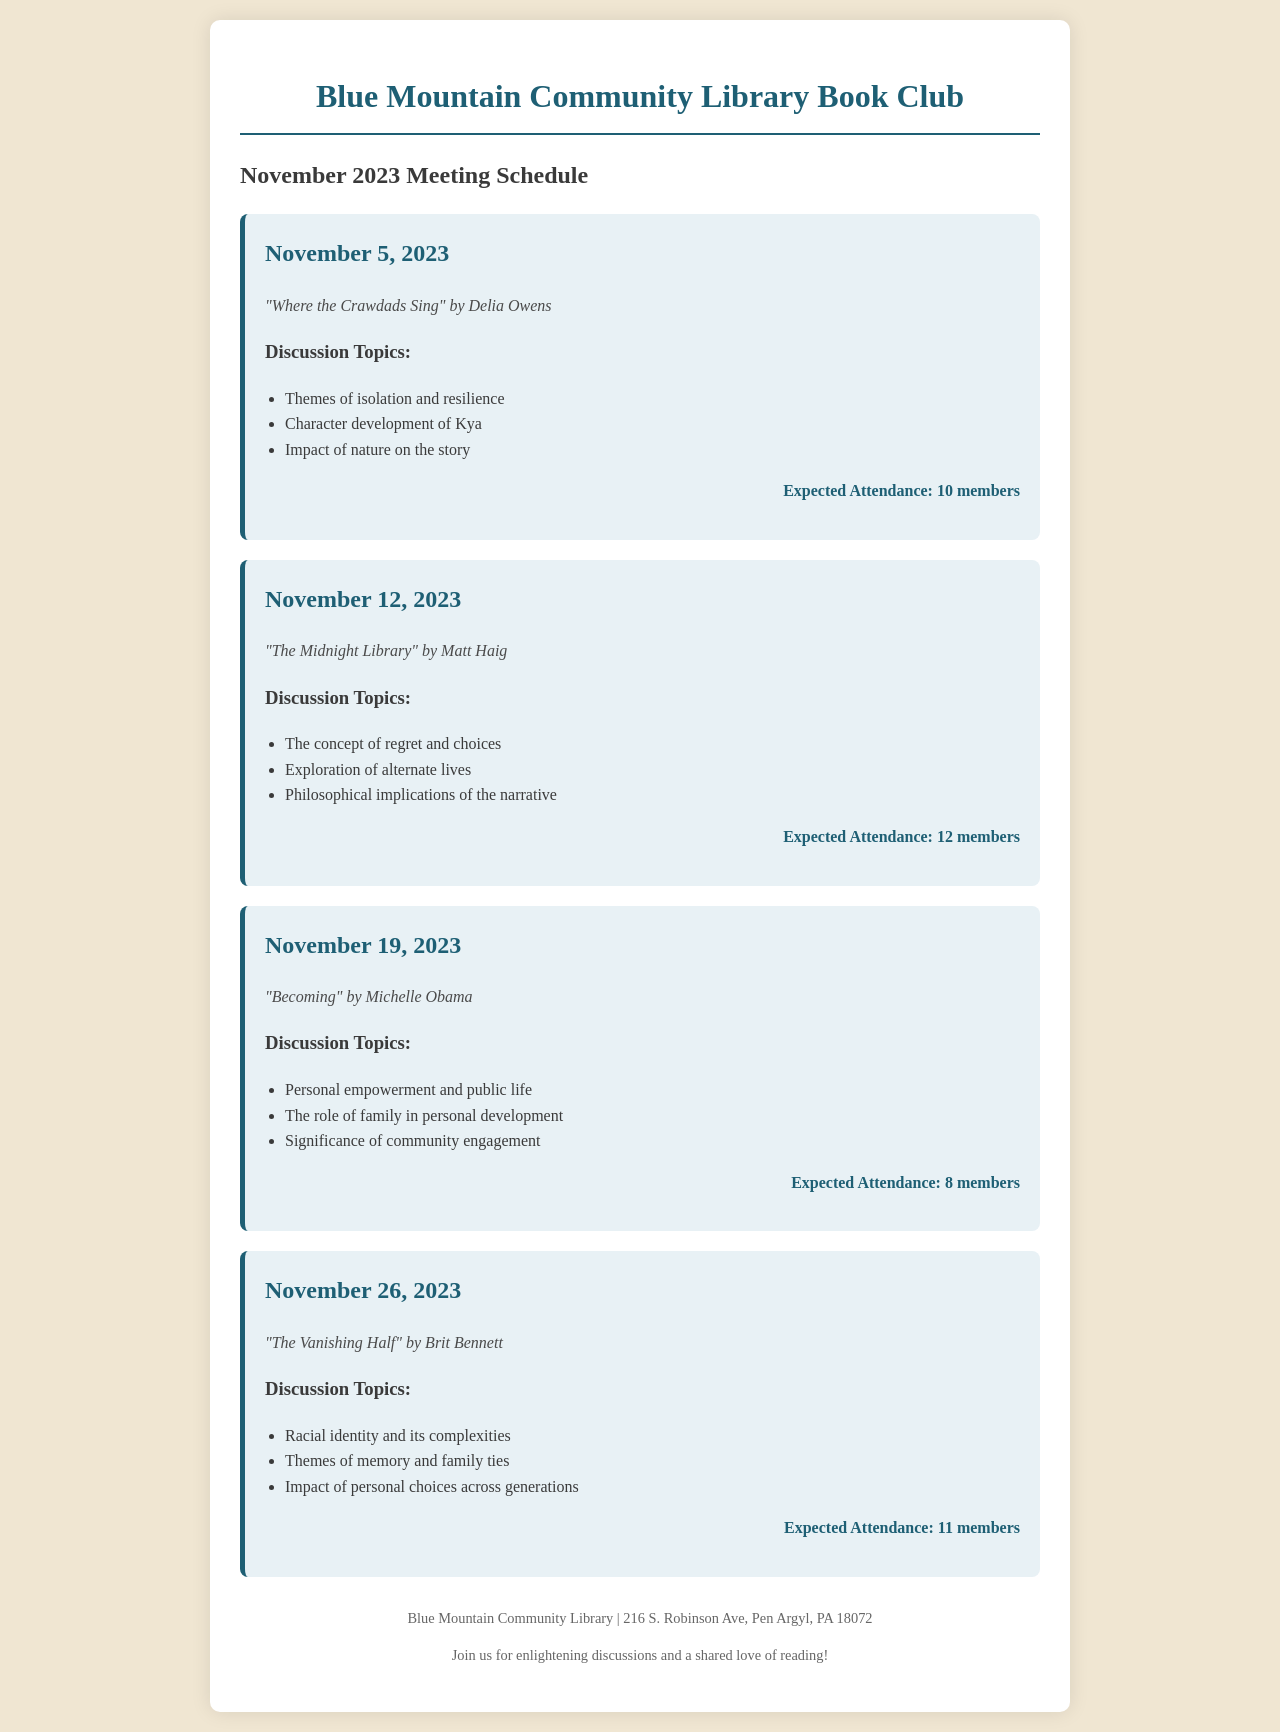What book is discussed on November 5, 2023? The book discussed on this date can be found in the document under the date section.
Answer: "Where the Crawdads Sing" What is the theme for the discussion on November 12, 2023? Themes are listed under each meeting's discussion topics.
Answer: The concept of regret and choices How many members are expected to attend the meeting on November 19, 2023? The expected attendance is noted at the end of the discussion topics for each meeting.
Answer: 8 members Which book explores racial identity? The book that discusses racial identity can be identified from the meeting details.
Answer: "The Vanishing Half" What date is the meeting focused on "Becoming" by Michelle Obama? The date of the meeting is part of the book details listed in the document.
Answer: November 19, 2023 What philosophical concept is discussed in "The Midnight Library"? The philosophical concept is mentioned in the discussion topics for that book.
Answer: Exploration of alternate lives How many total meetings are scheduled in November 2023? The number of meetings is counted based on the distinct entries visible in the document.
Answer: 4 meetings What is the address of the Blue Mountain Community Library? The library's address is provided at the end of the document.
Answer: 216 S. Robinson Ave, Pen Argyl, PA 18072 What is the color theme used for the headings in the document? The color theme for headings is specified under the style element for headings.
Answer: #1e5f74 